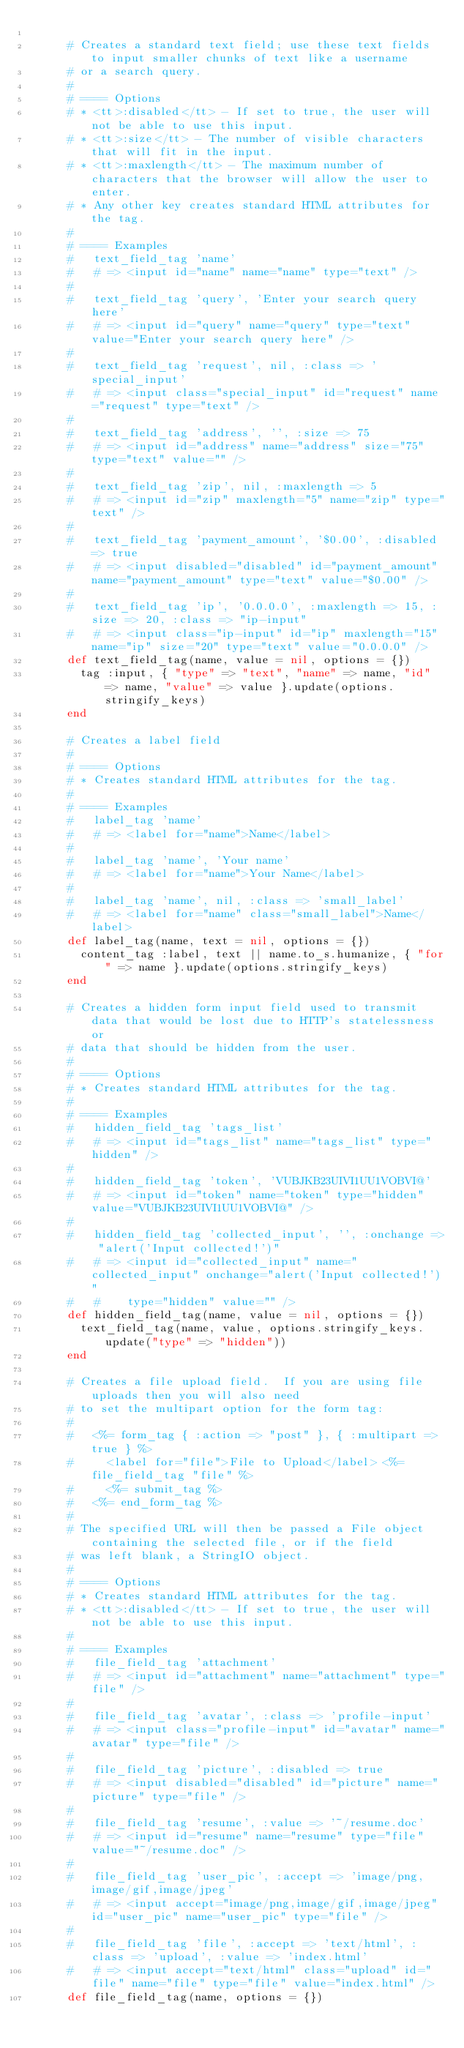Convert code to text. <code><loc_0><loc_0><loc_500><loc_500><_Ruby_>
      # Creates a standard text field; use these text fields to input smaller chunks of text like a username
      # or a search query.
      #
      # ==== Options
      # * <tt>:disabled</tt> - If set to true, the user will not be able to use this input.
      # * <tt>:size</tt> - The number of visible characters that will fit in the input.
      # * <tt>:maxlength</tt> - The maximum number of characters that the browser will allow the user to enter.
      # * Any other key creates standard HTML attributes for the tag.
      # 
      # ==== Examples
      #   text_field_tag 'name'
      #   # => <input id="name" name="name" type="text" />
      #
      #   text_field_tag 'query', 'Enter your search query here'
      #   # => <input id="query" name="query" type="text" value="Enter your search query here" />
      #
      #   text_field_tag 'request', nil, :class => 'special_input'
      #   # => <input class="special_input" id="request" name="request" type="text" />
      #
      #   text_field_tag 'address', '', :size => 75
      #   # => <input id="address" name="address" size="75" type="text" value="" />
      #
      #   text_field_tag 'zip', nil, :maxlength => 5
      #   # => <input id="zip" maxlength="5" name="zip" type="text" />
      #
      #   text_field_tag 'payment_amount', '$0.00', :disabled => true
      #   # => <input disabled="disabled" id="payment_amount" name="payment_amount" type="text" value="$0.00" />
      #
      #   text_field_tag 'ip', '0.0.0.0', :maxlength => 15, :size => 20, :class => "ip-input"
      #   # => <input class="ip-input" id="ip" maxlength="15" name="ip" size="20" type="text" value="0.0.0.0" />
      def text_field_tag(name, value = nil, options = {})
        tag :input, { "type" => "text", "name" => name, "id" => name, "value" => value }.update(options.stringify_keys)
      end

      # Creates a label field
      #
      # ==== Options  
      # * Creates standard HTML attributes for the tag.
      #
      # ==== Examples
      #   label_tag 'name'
      #   # => <label for="name">Name</label>
      #
      #   label_tag 'name', 'Your name'
      #   # => <label for="name">Your Name</label>
      #
      #   label_tag 'name', nil, :class => 'small_label'
      #   # => <label for="name" class="small_label">Name</label>
      def label_tag(name, text = nil, options = {})
        content_tag :label, text || name.to_s.humanize, { "for" => name }.update(options.stringify_keys)
      end

      # Creates a hidden form input field used to transmit data that would be lost due to HTTP's statelessness or
      # data that should be hidden from the user.
      #
      # ==== Options
      # * Creates standard HTML attributes for the tag.
      #
      # ==== Examples
      #   hidden_field_tag 'tags_list'
      #   # => <input id="tags_list" name="tags_list" type="hidden" />
      #
      #   hidden_field_tag 'token', 'VUBJKB23UIVI1UU1VOBVI@'
      #   # => <input id="token" name="token" type="hidden" value="VUBJKB23UIVI1UU1VOBVI@" />
      #
      #   hidden_field_tag 'collected_input', '', :onchange => "alert('Input collected!')"
      #   # => <input id="collected_input" name="collected_input" onchange="alert('Input collected!')" 
      #   #    type="hidden" value="" />
      def hidden_field_tag(name, value = nil, options = {})
        text_field_tag(name, value, options.stringify_keys.update("type" => "hidden"))
      end

      # Creates a file upload field.  If you are using file uploads then you will also need 
      # to set the multipart option for the form tag:
      #
      #   <%= form_tag { :action => "post" }, { :multipart => true } %>
      #     <label for="file">File to Upload</label> <%= file_field_tag "file" %>
      #     <%= submit_tag %>
      #   <%= end_form_tag %>
      #
      # The specified URL will then be passed a File object containing the selected file, or if the field 
      # was left blank, a StringIO object.
      #
      # ==== Options
      # * Creates standard HTML attributes for the tag.
      # * <tt>:disabled</tt> - If set to true, the user will not be able to use this input.
      #
      # ==== Examples
      #   file_field_tag 'attachment'
      #   # => <input id="attachment" name="attachment" type="file" />
      #
      #   file_field_tag 'avatar', :class => 'profile-input'
      #   # => <input class="profile-input" id="avatar" name="avatar" type="file" />
      #
      #   file_field_tag 'picture', :disabled => true
      #   # => <input disabled="disabled" id="picture" name="picture" type="file" />
      #
      #   file_field_tag 'resume', :value => '~/resume.doc'
      #   # => <input id="resume" name="resume" type="file" value="~/resume.doc" />
      #
      #   file_field_tag 'user_pic', :accept => 'image/png,image/gif,image/jpeg'
      #   # => <input accept="image/png,image/gif,image/jpeg" id="user_pic" name="user_pic" type="file" /> 
      #
      #   file_field_tag 'file', :accept => 'text/html', :class => 'upload', :value => 'index.html'
      #   # => <input accept="text/html" class="upload" id="file" name="file" type="file" value="index.html" />
      def file_field_tag(name, options = {})</code> 